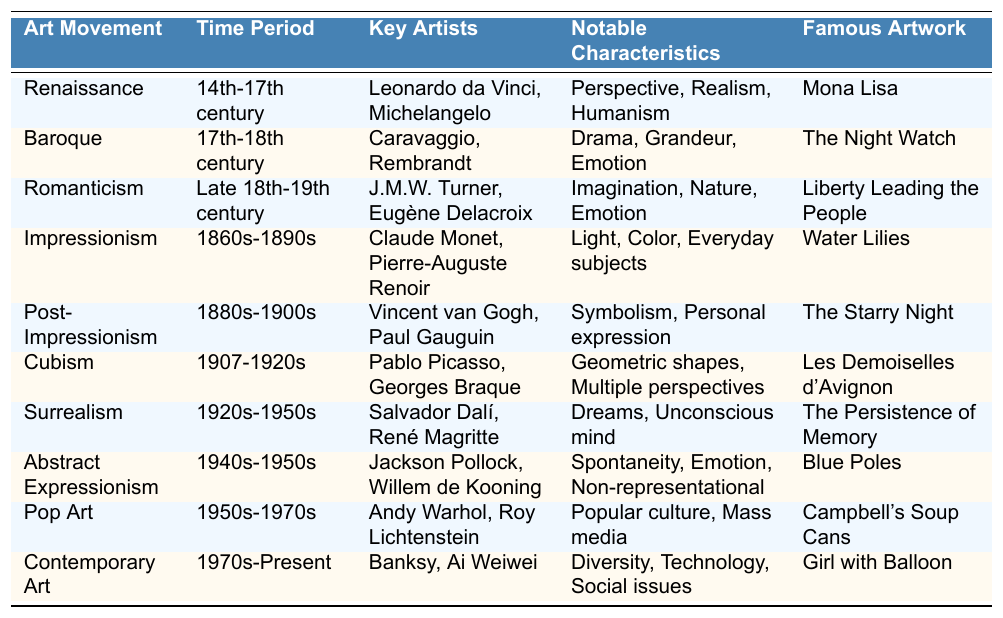What time period did the Baroque movement occur in? The Baroque movement is listed in the table under the "Time Period" column as "17th-18th century."
Answer: 17th-18th century Which art movement is characterized by "Dreams" and "Unconscious mind"? In the table, the movement with these characteristics is Surrealism, as specified in the "Notable Characteristics" column.
Answer: Surrealism Who are the key artists associated with the Renaissance? The table lists Leonardo da Vinci and Michelangelo as the key artists for the Renaissance in the "Key Artists" column.
Answer: Leonardo da Vinci, Michelangelo What is the famous artwork of Abstract Expressionism? The famous artwork associated with Abstract Expressionism, as mentioned in the "Famous Artwork" column, is "Blue Poles."
Answer: Blue Poles Which art movement comes after Impressionism? The movement that follows Impressionism, as per the "Time Period" sequence in the table, is Post-Impressionism.
Answer: Post-Impressionism Is the artwork "Liberty Leading the People" associated with Cubism? No, "Liberty Leading the People" is associated with Romanticism, not Cubism, as indicated in the "Famous Artwork" column.
Answer: No How many art movements were active in the 20th century? The table lists five movements linked to the 20th century: Cubism, Surrealism, Abstract Expressionism, Pop Art, and Contemporary Art, totaling five movements.
Answer: 5 What notable characteristic is shared between Impressionism and Post-Impressionism? Both movements are noted for their focus on "Emotion" in their characteristics, as indicated in the respective "Notable Characteristics" columns.
Answer: Emotion Which movement includes Paul Gauguin as a key artist? Paul Gauguin is mentioned under the key artists of the Post-Impressionism movement in the "Key Artists" column of the table.
Answer: Post-Impressionism What is the primary focus of Pop Art based on the characteristics listed? The main focus of Pop Art includes "Popular culture" and "Mass media," as specified in the "Notable Characteristics" column.
Answer: Popular culture, Mass media Compare the time periods of Surrealism and Contemporary Art. Surrealism occurred from the 1920s to the 1950s, while Contemporary Art spans from the 1970s to the present, showing that Contemporary Art began several decades later.
Answer: Contemporary Art starts later than Surrealism 